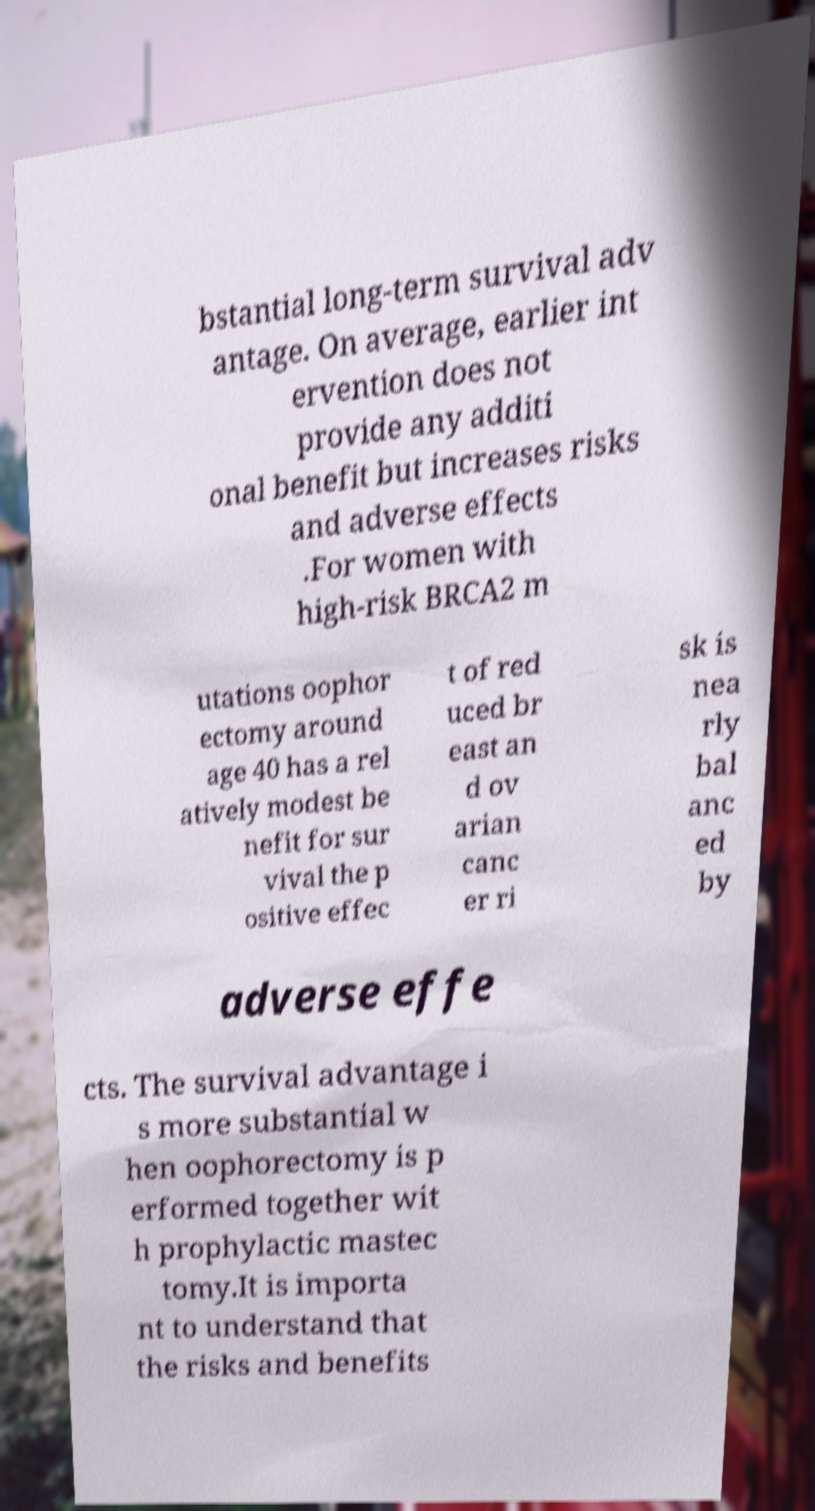Can you read and provide the text displayed in the image?This photo seems to have some interesting text. Can you extract and type it out for me? bstantial long-term survival adv antage. On average, earlier int ervention does not provide any additi onal benefit but increases risks and adverse effects .For women with high-risk BRCA2 m utations oophor ectomy around age 40 has a rel atively modest be nefit for sur vival the p ositive effec t of red uced br east an d ov arian canc er ri sk is nea rly bal anc ed by adverse effe cts. The survival advantage i s more substantial w hen oophorectomy is p erformed together wit h prophylactic mastec tomy.It is importa nt to understand that the risks and benefits 